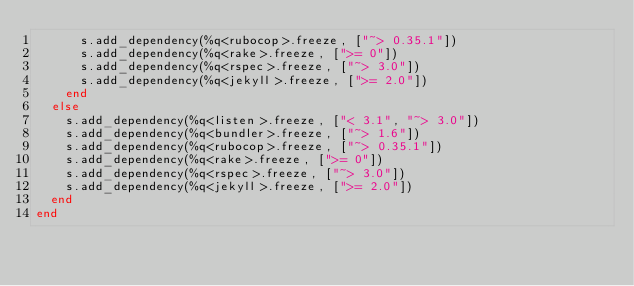<code> <loc_0><loc_0><loc_500><loc_500><_Ruby_>      s.add_dependency(%q<rubocop>.freeze, ["~> 0.35.1"])
      s.add_dependency(%q<rake>.freeze, [">= 0"])
      s.add_dependency(%q<rspec>.freeze, ["~> 3.0"])
      s.add_dependency(%q<jekyll>.freeze, [">= 2.0"])
    end
  else
    s.add_dependency(%q<listen>.freeze, ["< 3.1", "~> 3.0"])
    s.add_dependency(%q<bundler>.freeze, ["~> 1.6"])
    s.add_dependency(%q<rubocop>.freeze, ["~> 0.35.1"])
    s.add_dependency(%q<rake>.freeze, [">= 0"])
    s.add_dependency(%q<rspec>.freeze, ["~> 3.0"])
    s.add_dependency(%q<jekyll>.freeze, [">= 2.0"])
  end
end
</code> 